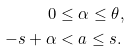Convert formula to latex. <formula><loc_0><loc_0><loc_500><loc_500>0 & \leq \alpha \leq \theta , \\ - s + \alpha & < a \leq s .</formula> 